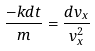<formula> <loc_0><loc_0><loc_500><loc_500>\frac { - k d t } { m } = \frac { d v _ { x } } { v _ { x } ^ { 2 } }</formula> 